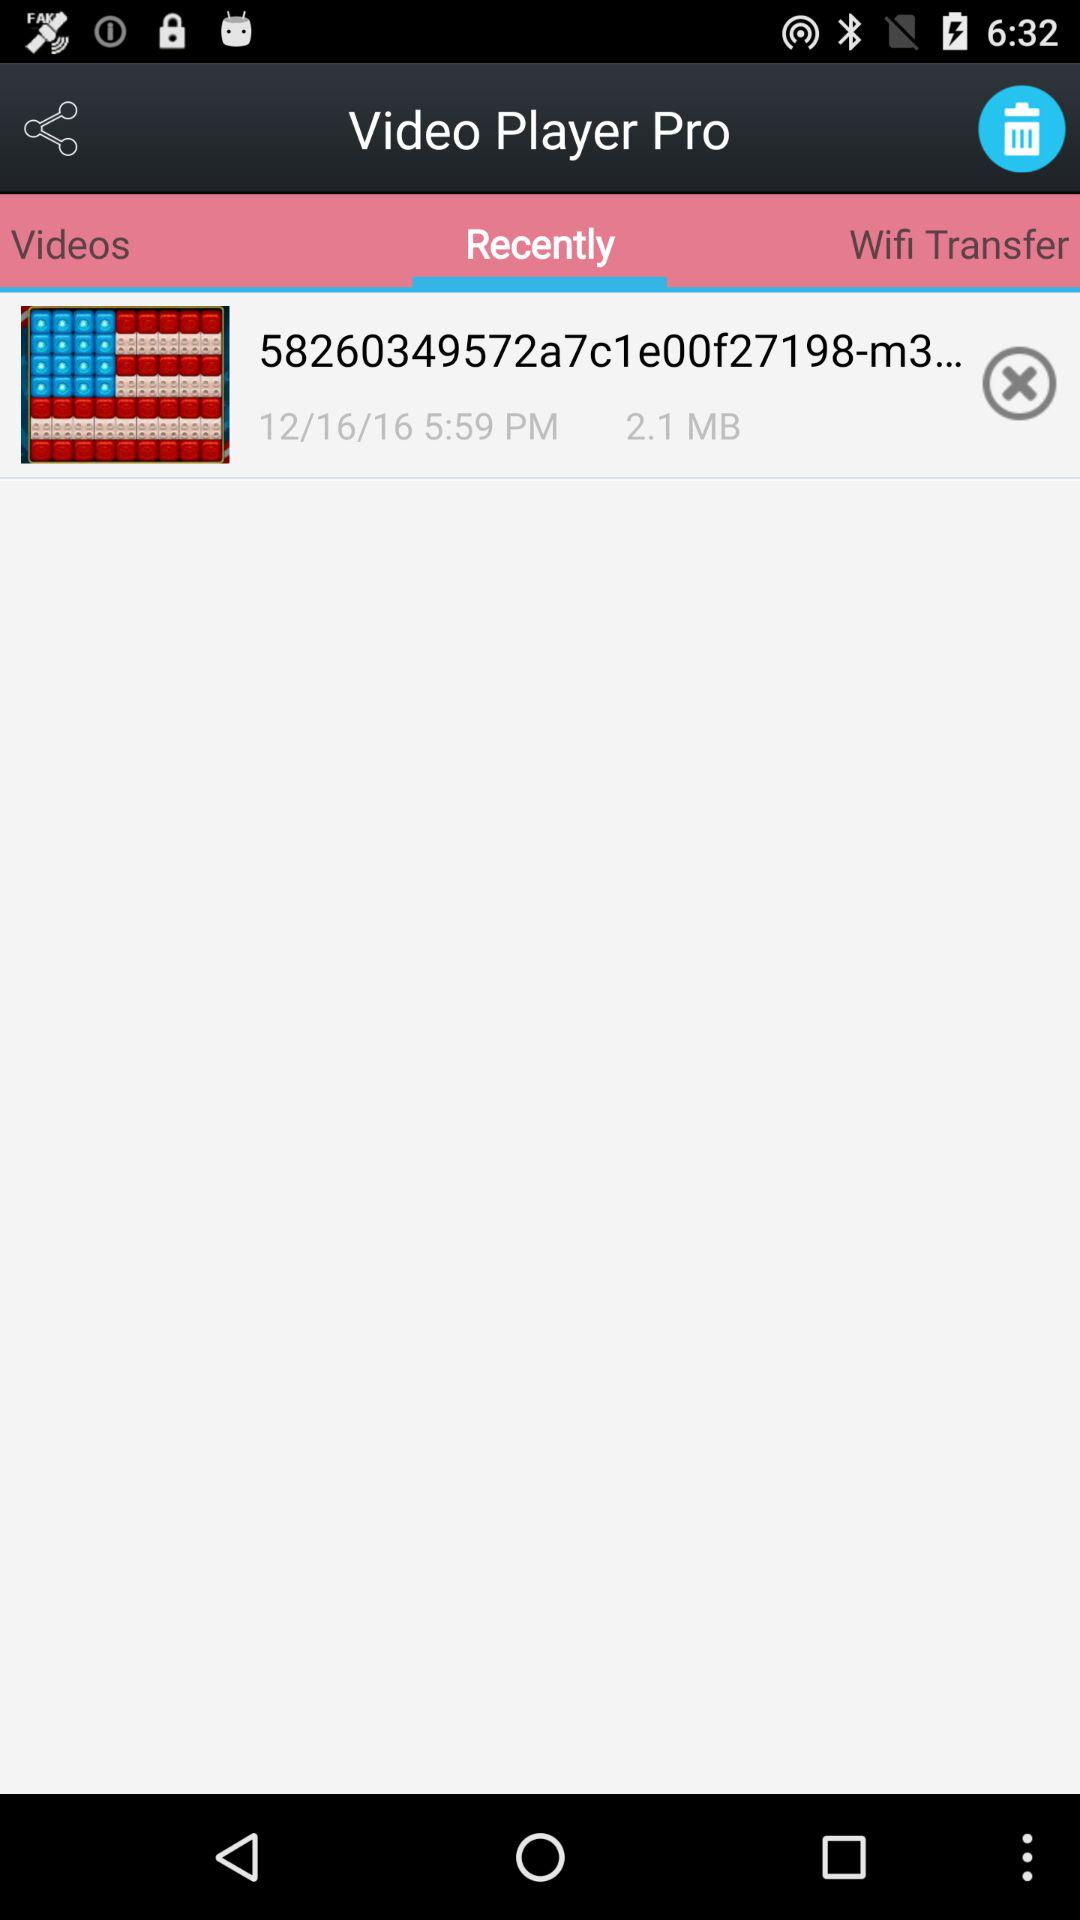Which is the selected tab? The selected tab is "Recently". 